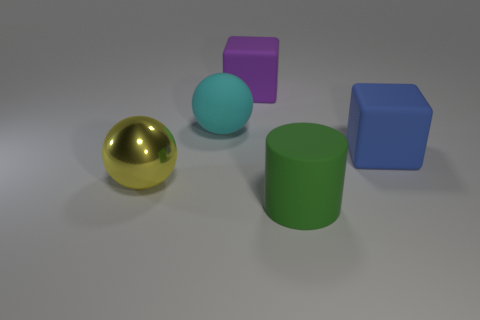What shape is the big object that is left of the matte thing on the left side of the rubber cube that is behind the cyan rubber thing?
Provide a short and direct response. Sphere. There is another large cube that is made of the same material as the blue cube; what color is it?
Offer a very short reply. Purple. There is a large sphere that is in front of the big block on the right side of the large rubber object that is in front of the big yellow metallic ball; what color is it?
Provide a short and direct response. Yellow. How many spheres are big rubber objects or big blue things?
Provide a short and direct response. 1. The large shiny thing has what color?
Your answer should be very brief. Yellow. How many things are either green spheres or large yellow spheres?
Keep it short and to the point. 1. What material is the yellow ball that is the same size as the blue rubber cube?
Ensure brevity in your answer.  Metal. What is the big purple object made of?
Make the answer very short. Rubber. How many things are either big things that are in front of the large cyan rubber thing or big purple matte blocks to the left of the large cylinder?
Offer a very short reply. 4. How many other objects are there of the same color as the cylinder?
Offer a very short reply. 0. 